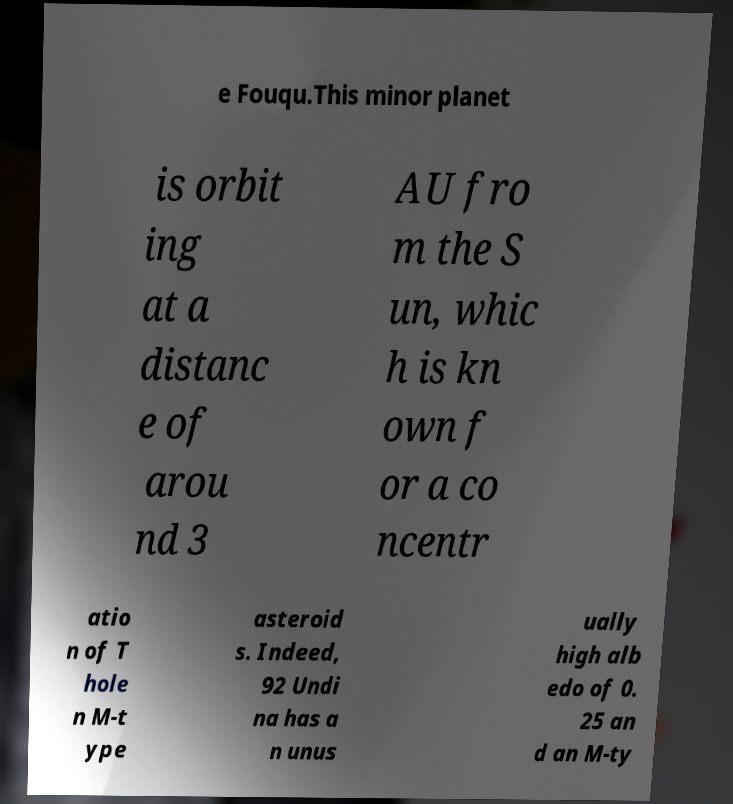Can you read and provide the text displayed in the image?This photo seems to have some interesting text. Can you extract and type it out for me? e Fouqu.This minor planet is orbit ing at a distanc e of arou nd 3 AU fro m the S un, whic h is kn own f or a co ncentr atio n of T hole n M-t ype asteroid s. Indeed, 92 Undi na has a n unus ually high alb edo of 0. 25 an d an M-ty 